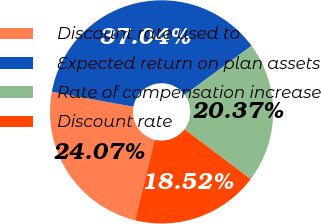Convert chart to OTSL. <chart><loc_0><loc_0><loc_500><loc_500><pie_chart><fcel>Discount rate used to<fcel>Expected return on plan assets<fcel>Rate of compensation increase<fcel>Discount rate<nl><fcel>24.07%<fcel>37.04%<fcel>20.37%<fcel>18.52%<nl></chart> 